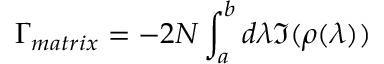<formula> <loc_0><loc_0><loc_500><loc_500>\Gamma _ { m a t r i x } = - 2 N \int _ { a } ^ { b } d \lambda \Im ( \rho ( \lambda ) )</formula> 